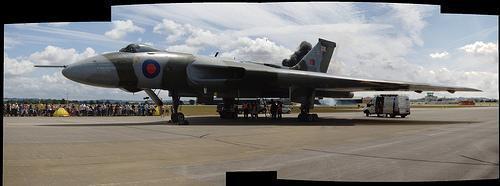How many airplanes are there?
Give a very brief answer. 1. 